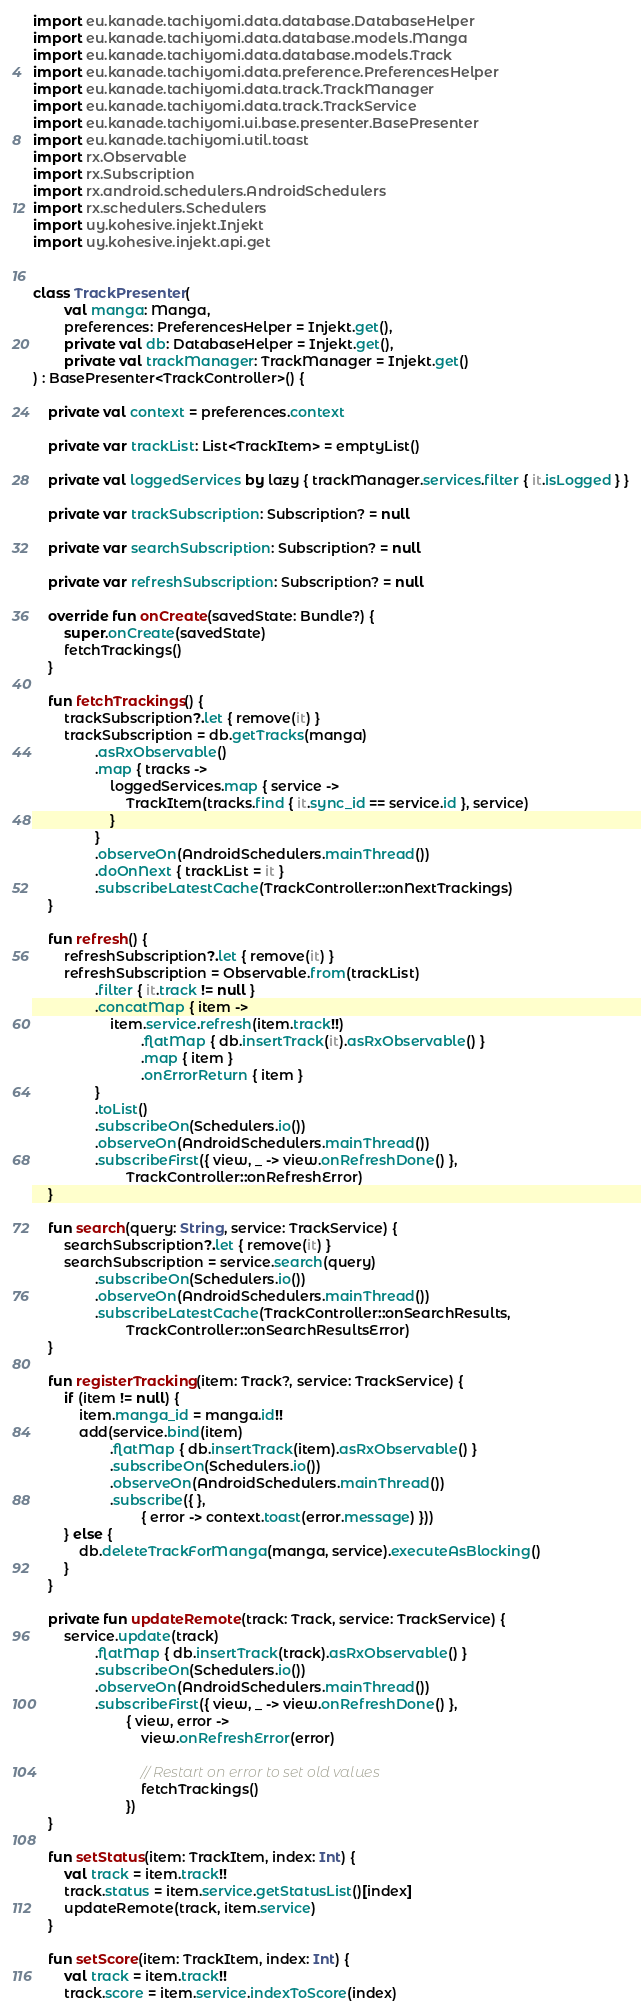<code> <loc_0><loc_0><loc_500><loc_500><_Kotlin_>import eu.kanade.tachiyomi.data.database.DatabaseHelper
import eu.kanade.tachiyomi.data.database.models.Manga
import eu.kanade.tachiyomi.data.database.models.Track
import eu.kanade.tachiyomi.data.preference.PreferencesHelper
import eu.kanade.tachiyomi.data.track.TrackManager
import eu.kanade.tachiyomi.data.track.TrackService
import eu.kanade.tachiyomi.ui.base.presenter.BasePresenter
import eu.kanade.tachiyomi.util.toast
import rx.Observable
import rx.Subscription
import rx.android.schedulers.AndroidSchedulers
import rx.schedulers.Schedulers
import uy.kohesive.injekt.Injekt
import uy.kohesive.injekt.api.get


class TrackPresenter(
        val manga: Manga,
        preferences: PreferencesHelper = Injekt.get(),
        private val db: DatabaseHelper = Injekt.get(),
        private val trackManager: TrackManager = Injekt.get()
) : BasePresenter<TrackController>() {

    private val context = preferences.context

    private var trackList: List<TrackItem> = emptyList()

    private val loggedServices by lazy { trackManager.services.filter { it.isLogged } }

    private var trackSubscription: Subscription? = null

    private var searchSubscription: Subscription? = null

    private var refreshSubscription: Subscription? = null

    override fun onCreate(savedState: Bundle?) {
        super.onCreate(savedState)
        fetchTrackings()
    }

    fun fetchTrackings() {
        trackSubscription?.let { remove(it) }
        trackSubscription = db.getTracks(manga)
                .asRxObservable()
                .map { tracks ->
                    loggedServices.map { service ->
                        TrackItem(tracks.find { it.sync_id == service.id }, service)
                    }
                }
                .observeOn(AndroidSchedulers.mainThread())
                .doOnNext { trackList = it }
                .subscribeLatestCache(TrackController::onNextTrackings)
    }

    fun refresh() {
        refreshSubscription?.let { remove(it) }
        refreshSubscription = Observable.from(trackList)
                .filter { it.track != null }
                .concatMap { item ->
                    item.service.refresh(item.track!!)
                            .flatMap { db.insertTrack(it).asRxObservable() }
                            .map { item }
                            .onErrorReturn { item }
                }
                .toList()
                .subscribeOn(Schedulers.io())
                .observeOn(AndroidSchedulers.mainThread())
                .subscribeFirst({ view, _ -> view.onRefreshDone() },
                        TrackController::onRefreshError)
    }

    fun search(query: String, service: TrackService) {
        searchSubscription?.let { remove(it) }
        searchSubscription = service.search(query)
                .subscribeOn(Schedulers.io())
                .observeOn(AndroidSchedulers.mainThread())
                .subscribeLatestCache(TrackController::onSearchResults,
                        TrackController::onSearchResultsError)
    }

    fun registerTracking(item: Track?, service: TrackService) {
        if (item != null) {
            item.manga_id = manga.id!!
            add(service.bind(item)
                    .flatMap { db.insertTrack(item).asRxObservable() }
                    .subscribeOn(Schedulers.io())
                    .observeOn(AndroidSchedulers.mainThread())
                    .subscribe({ },
                            { error -> context.toast(error.message) }))
        } else {
            db.deleteTrackForManga(manga, service).executeAsBlocking()
        }
    }

    private fun updateRemote(track: Track, service: TrackService) {
        service.update(track)
                .flatMap { db.insertTrack(track).asRxObservable() }
                .subscribeOn(Schedulers.io())
                .observeOn(AndroidSchedulers.mainThread())
                .subscribeFirst({ view, _ -> view.onRefreshDone() },
                        { view, error ->
                            view.onRefreshError(error)

                            // Restart on error to set old values
                            fetchTrackings()
                        })
    }

    fun setStatus(item: TrackItem, index: Int) {
        val track = item.track!!
        track.status = item.service.getStatusList()[index]
        updateRemote(track, item.service)
    }

    fun setScore(item: TrackItem, index: Int) {
        val track = item.track!!
        track.score = item.service.indexToScore(index)</code> 